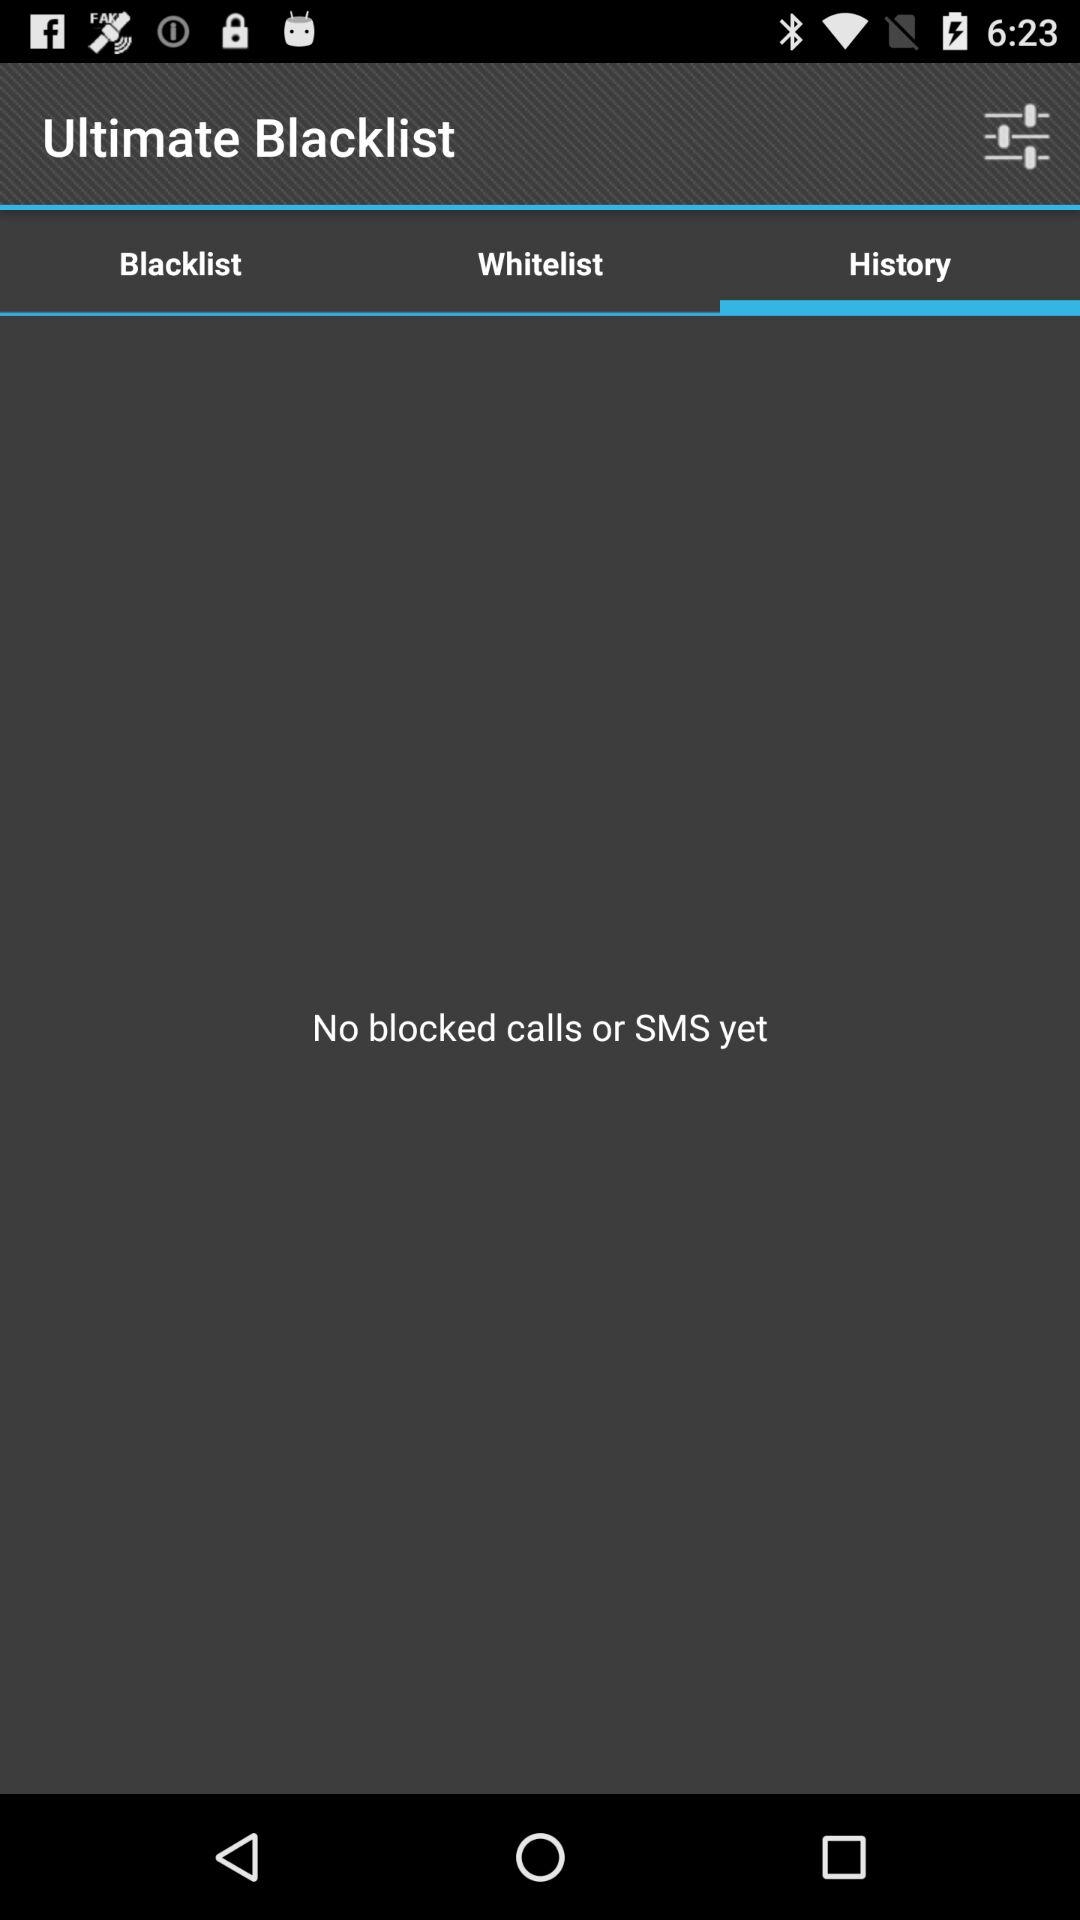Which tab is selected? The selected tab is "History". 